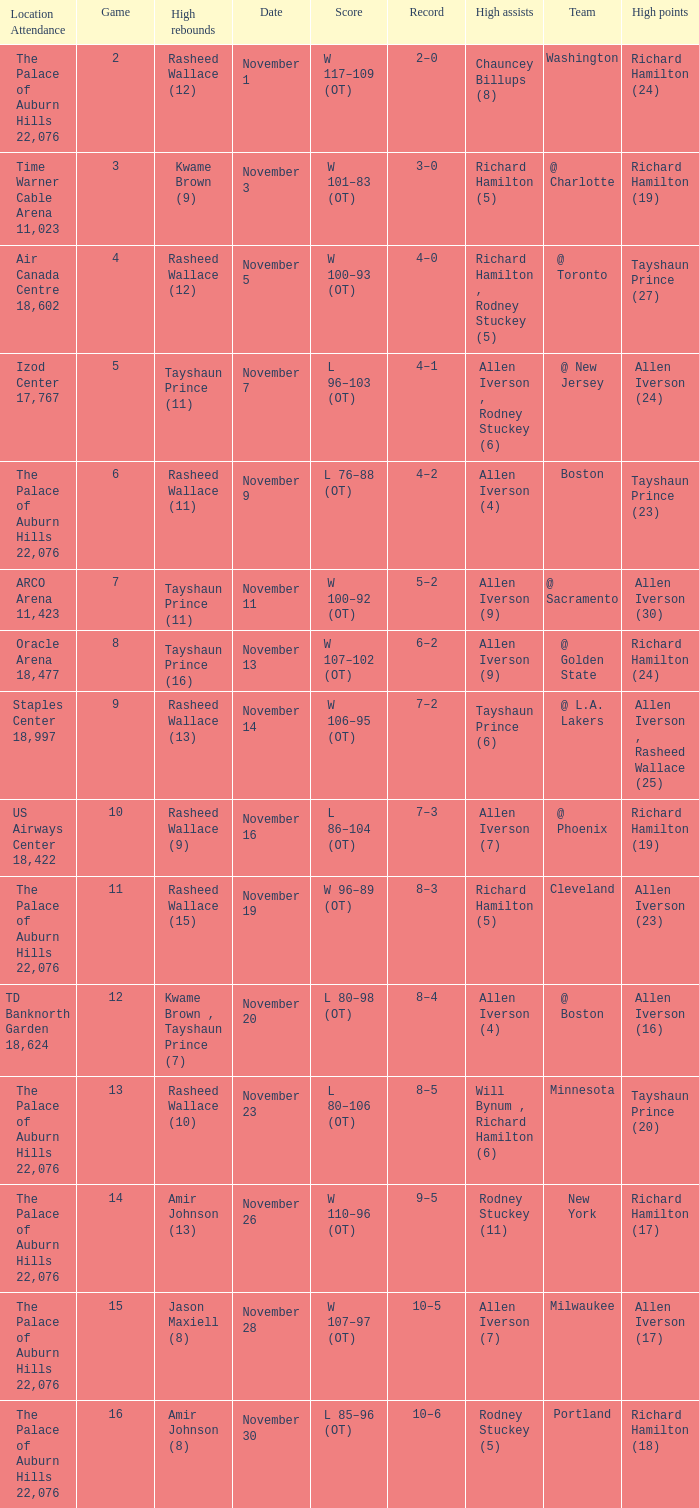What is High Points, when Game is "5"? Allen Iverson (24). 